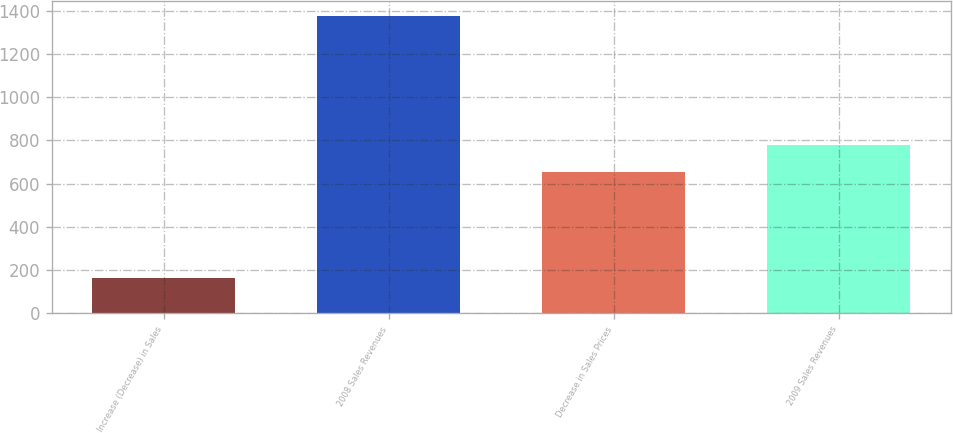Convert chart. <chart><loc_0><loc_0><loc_500><loc_500><bar_chart><fcel>Increase (Decrease) in Sales<fcel>2008 Sales Revenues<fcel>Decrease in Sales Prices<fcel>2009 Sales Revenues<nl><fcel>165<fcel>1375<fcel>655<fcel>776<nl></chart> 